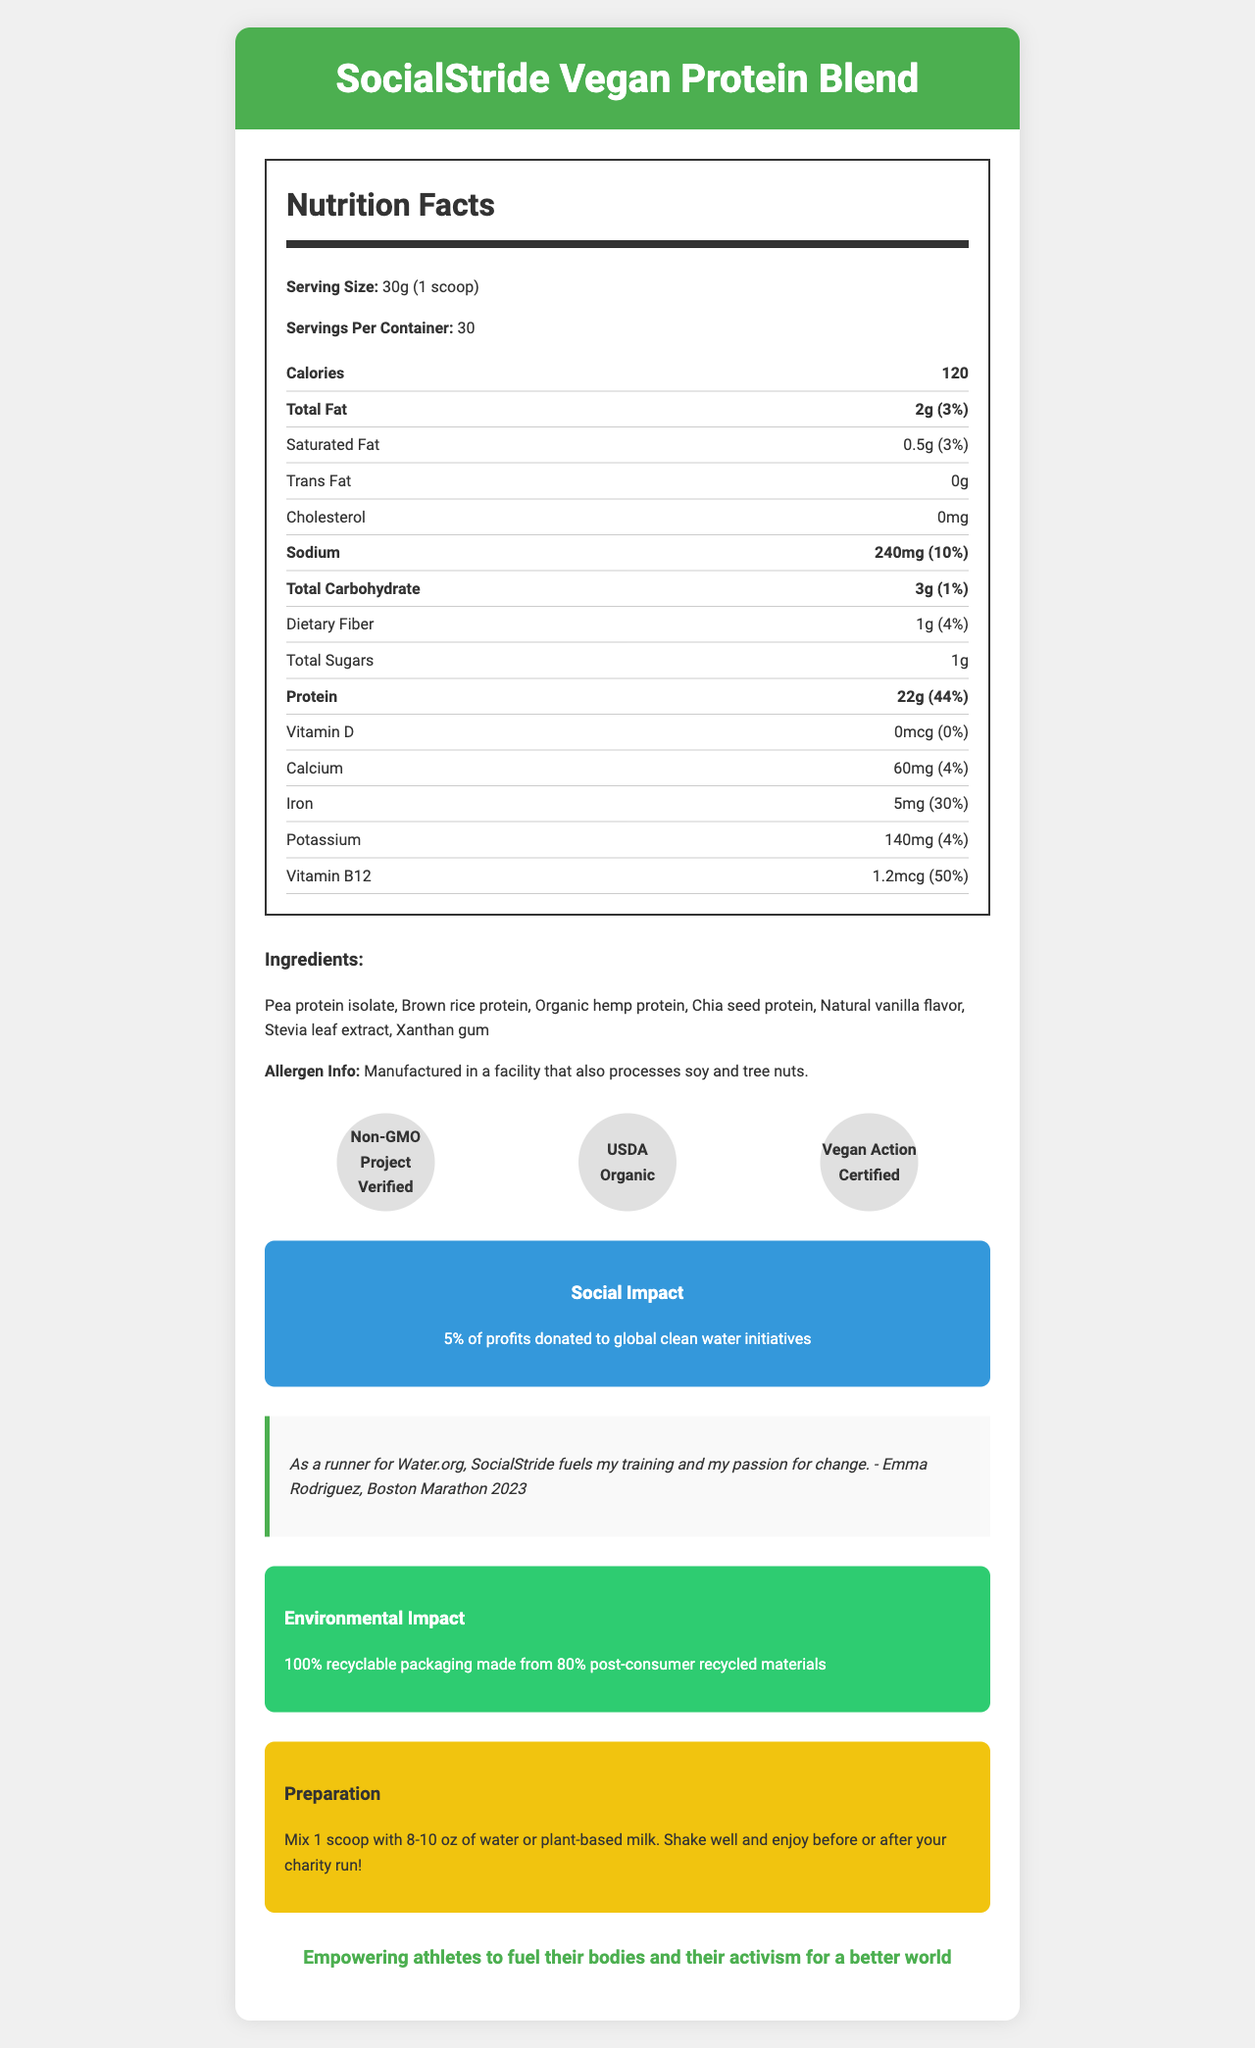what is the serving size of SocialStride Vegan Protein Blend? The serving size is listed at the top of the Nutrition Facts section.
Answer: 30g (1 scoop) how many servings are there per container? The number of servings per container is specified right next to the serving size.
Answer: 30 how many calories does each serving contain? The calorie content per serving is clearly labeled under the Nutritional Facts.
Answer: 120 what percentage of daily value is the dietary fiber? The daily value percentage for dietary fiber is mentioned in the nutrition item detailing dietary fiber.
Answer: 4% what are the ingredients in SocialStride Vegan Protein Blend? The ingredients are listed under the Ingredients section.
Answer: Pea protein isolate, Brown rice protein, Organic hemp protein, Chia seed protein, Natural vanilla flavor, Stevia leaf extract, Xanthan gum which social cause does this product support? A. Environmental conservation B. Renewable energy C. Global clean water initiatives D. Education for all The Social Impact section states that 5% of profits are donated to global clean water initiatives.
Answer: C what is the certification status of the product? A. Non-GMO Project Verified B. USDA Organic C. Vegan Action Certified D. All of the above The Certifications section showcases all these certifications; therefore, the correct answer is all of the above.
Answer: D is there any cholesterol in this product? The Nutrition Facts section lists cholesterol content as 0mg.
Answer: No is this product suitable for someone allergic to tree nuts? The allergen information states that the product is manufactured in a facility that processes tree nuts.
Answer: No summarize the key details provided in the document. The document contains extensive information about the product's nutritional value, ingredients, allergen warnings, and various certifications. It also highlights the company's social and environmental commitments, a testimonial from an athlete, and preparation instructions.
Answer: The document provides detailed nutritional information, ingredients list, allergen information, certifications, social impact, a testimonial, environmental info, preparation instructions, and the company mission of SocialStride Vegan Protein Blend. why did Emma Rodriguez endorse this product? While Emma Rodriguez's endorsement is featured, the document does not provide specific reasons behind her endorsement.
Answer: Not enough information does the product contain added sugars? The product contains 1g of total sugars as indicated in the Nutritional Facts.
Answer: Yes what is the amount of sodium per serving and its daily value percentage? The sodium content per serving is 240mg, and it contributes 10% to the daily value, as stated in the Nutrition Facts.
Answer: 240mg, 10% who benefits from the social impact initiatives of the product? The Social Impact section notes that 5% of profits are donated to global clean water initiatives.
Answer: Global clean water initiatives is this product designed to be mixed with water only? The preparation instructions suggest mixing one scoop with either water or plant-based milk.
Answer: No 